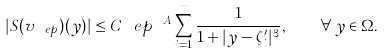<formula> <loc_0><loc_0><loc_500><loc_500>| S ( v _ { \ e p } ) ( y ) | \leq C \ e p ^ { \ A } \sum _ { i = 1 } ^ { m } \frac { 1 } { 1 + | y - \zeta _ { i } ^ { \prime } | ^ { 3 } } , \quad \forall \, y \in \Omega .</formula> 